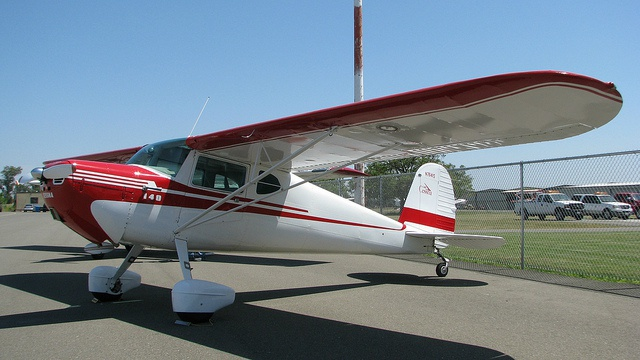Describe the objects in this image and their specific colors. I can see airplane in gray, black, maroon, and lightgray tones, truck in gray and black tones, truck in gray, black, and darkgray tones, car in gray, black, maroon, and purple tones, and truck in gray, black, maroon, and purple tones in this image. 